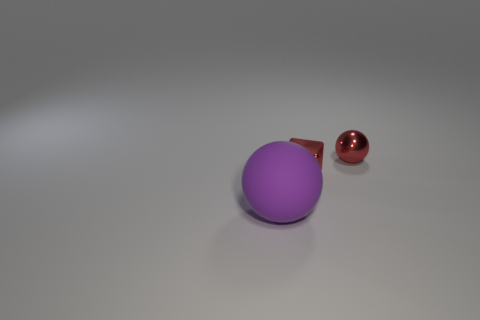The other thing that is the same shape as the big purple rubber object is what color?
Offer a terse response. Red. The red ball is what size?
Keep it short and to the point. Small. What number of blocks are either small yellow matte things or tiny shiny things?
Your response must be concise. 1. What size is the metallic object that is the same shape as the rubber thing?
Offer a very short reply. Small. What number of green matte blocks are there?
Your answer should be very brief. 0. There is a purple object; does it have the same shape as the tiny red object that is behind the red block?
Your answer should be very brief. Yes. There is a ball behind the rubber ball; what size is it?
Provide a short and direct response. Small. What is the material of the red block?
Ensure brevity in your answer.  Metal. Does the small shiny thing that is right of the tiny red metallic block have the same shape as the rubber object?
Provide a short and direct response. Yes. There is a block that is the same color as the small ball; what size is it?
Your response must be concise. Small. 